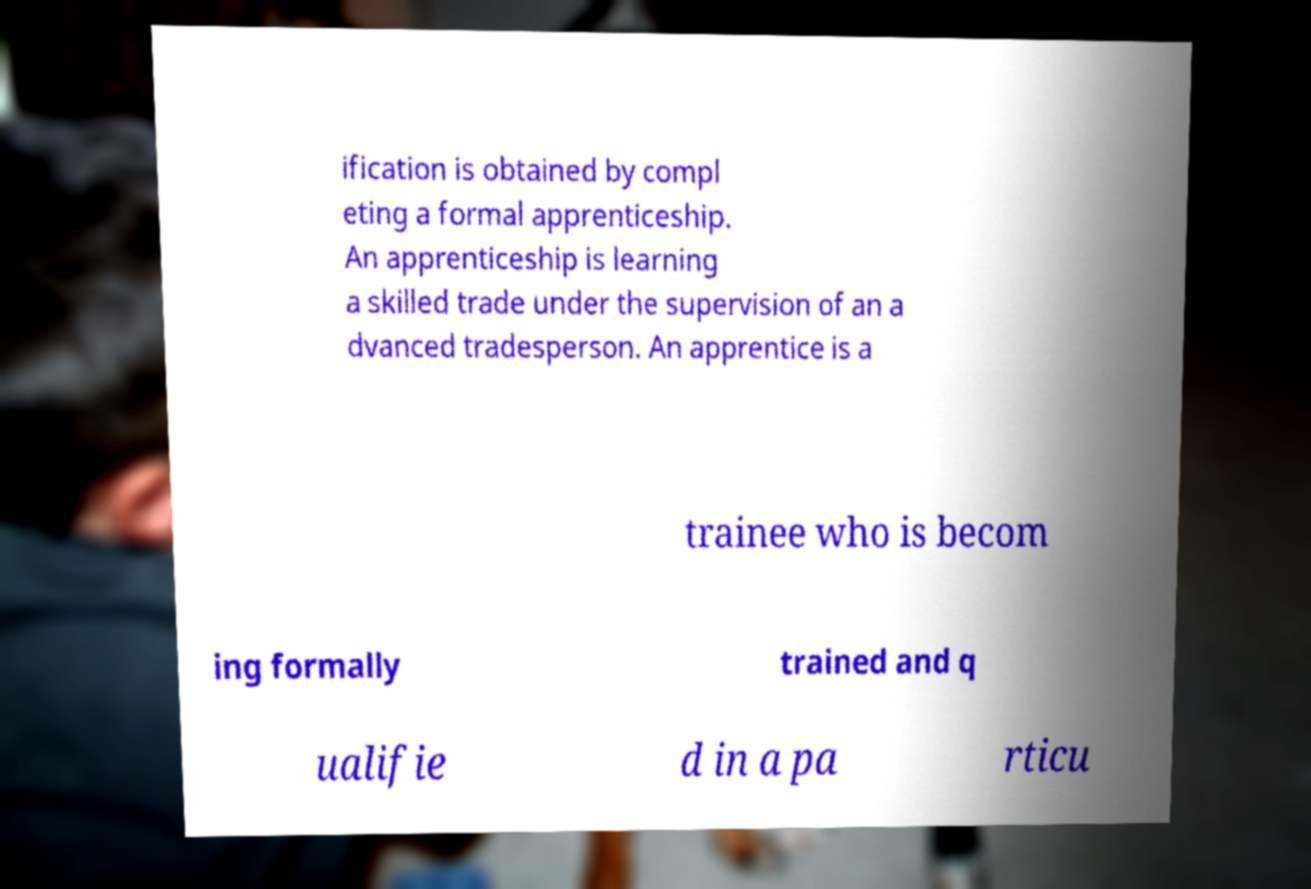Can you accurately transcribe the text from the provided image for me? ification is obtained by compl eting a formal apprenticeship. An apprenticeship is learning a skilled trade under the supervision of an a dvanced tradesperson. An apprentice is a trainee who is becom ing formally trained and q ualifie d in a pa rticu 